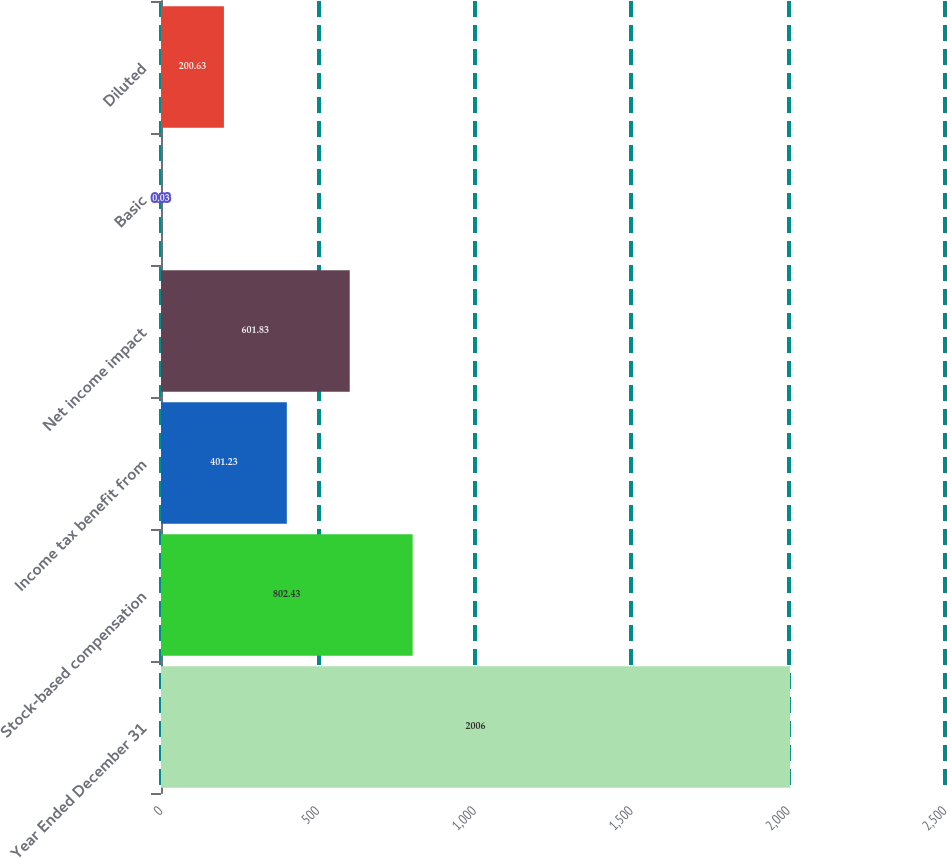Convert chart to OTSL. <chart><loc_0><loc_0><loc_500><loc_500><bar_chart><fcel>Year Ended December 31<fcel>Stock-based compensation<fcel>Income tax benefit from<fcel>Net income impact<fcel>Basic<fcel>Diluted<nl><fcel>2006<fcel>802.43<fcel>401.23<fcel>601.83<fcel>0.03<fcel>200.63<nl></chart> 